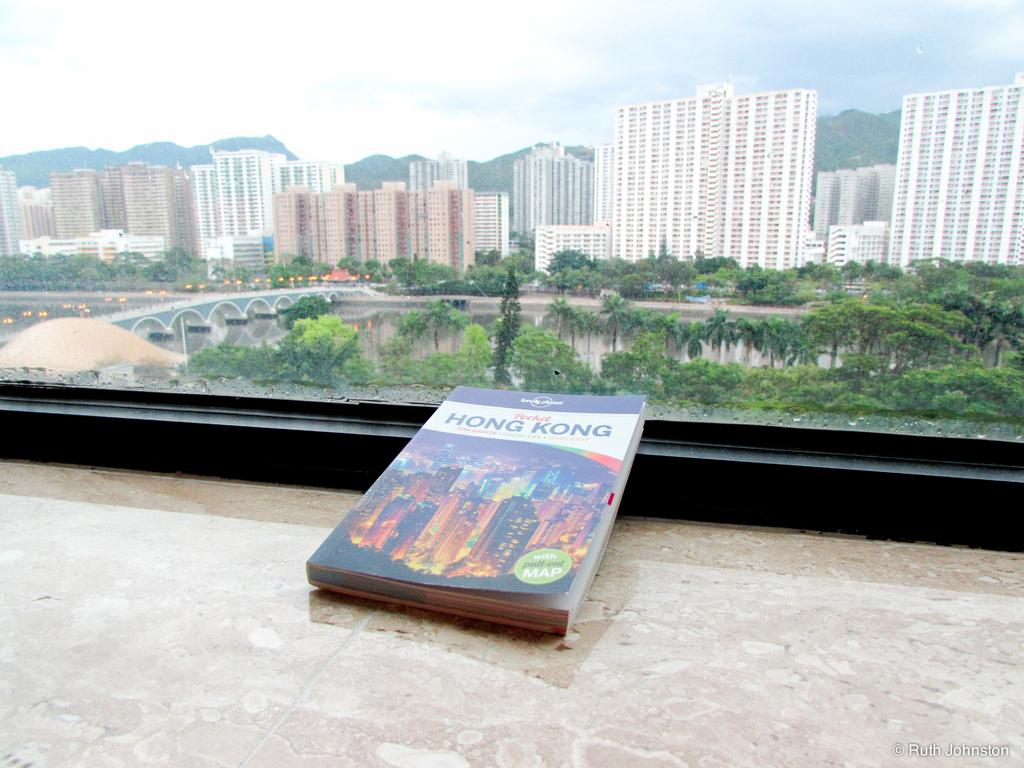What object is placed on a wall in the image? There is a book on a wall in the image. What can be seen through the glass in the image? A lake, a bridge, trees, buildings, mountains, and the sky are visible through the glass. What type of container is present in the image? There is a glass in the image. What type of volcano can be seen erupting in the image? There is no volcano present in the image. Can you hear the sound of a rainstorm in the image? The image is a still picture, so it does not contain any sound, including the sound of a rainstorm. 